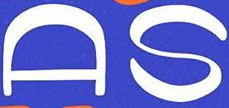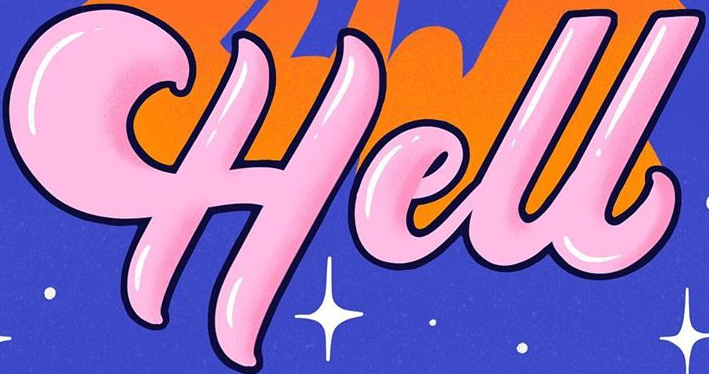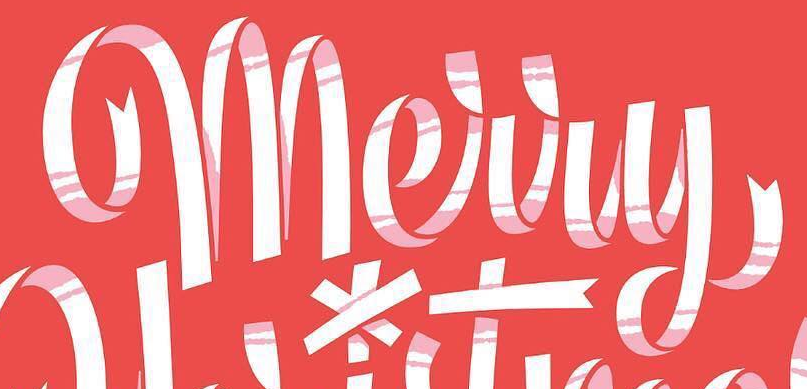Read the text content from these images in order, separated by a semicolon. AS; Hell; Merry 